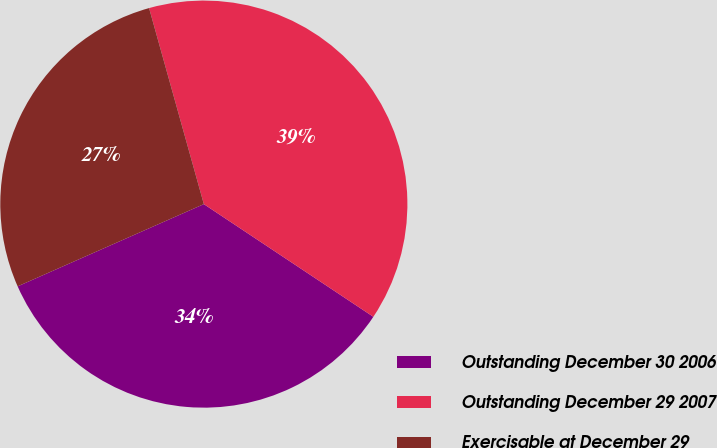<chart> <loc_0><loc_0><loc_500><loc_500><pie_chart><fcel>Outstanding December 30 2006<fcel>Outstanding December 29 2007<fcel>Exercisable at December 29<nl><fcel>34.04%<fcel>38.67%<fcel>27.28%<nl></chart> 